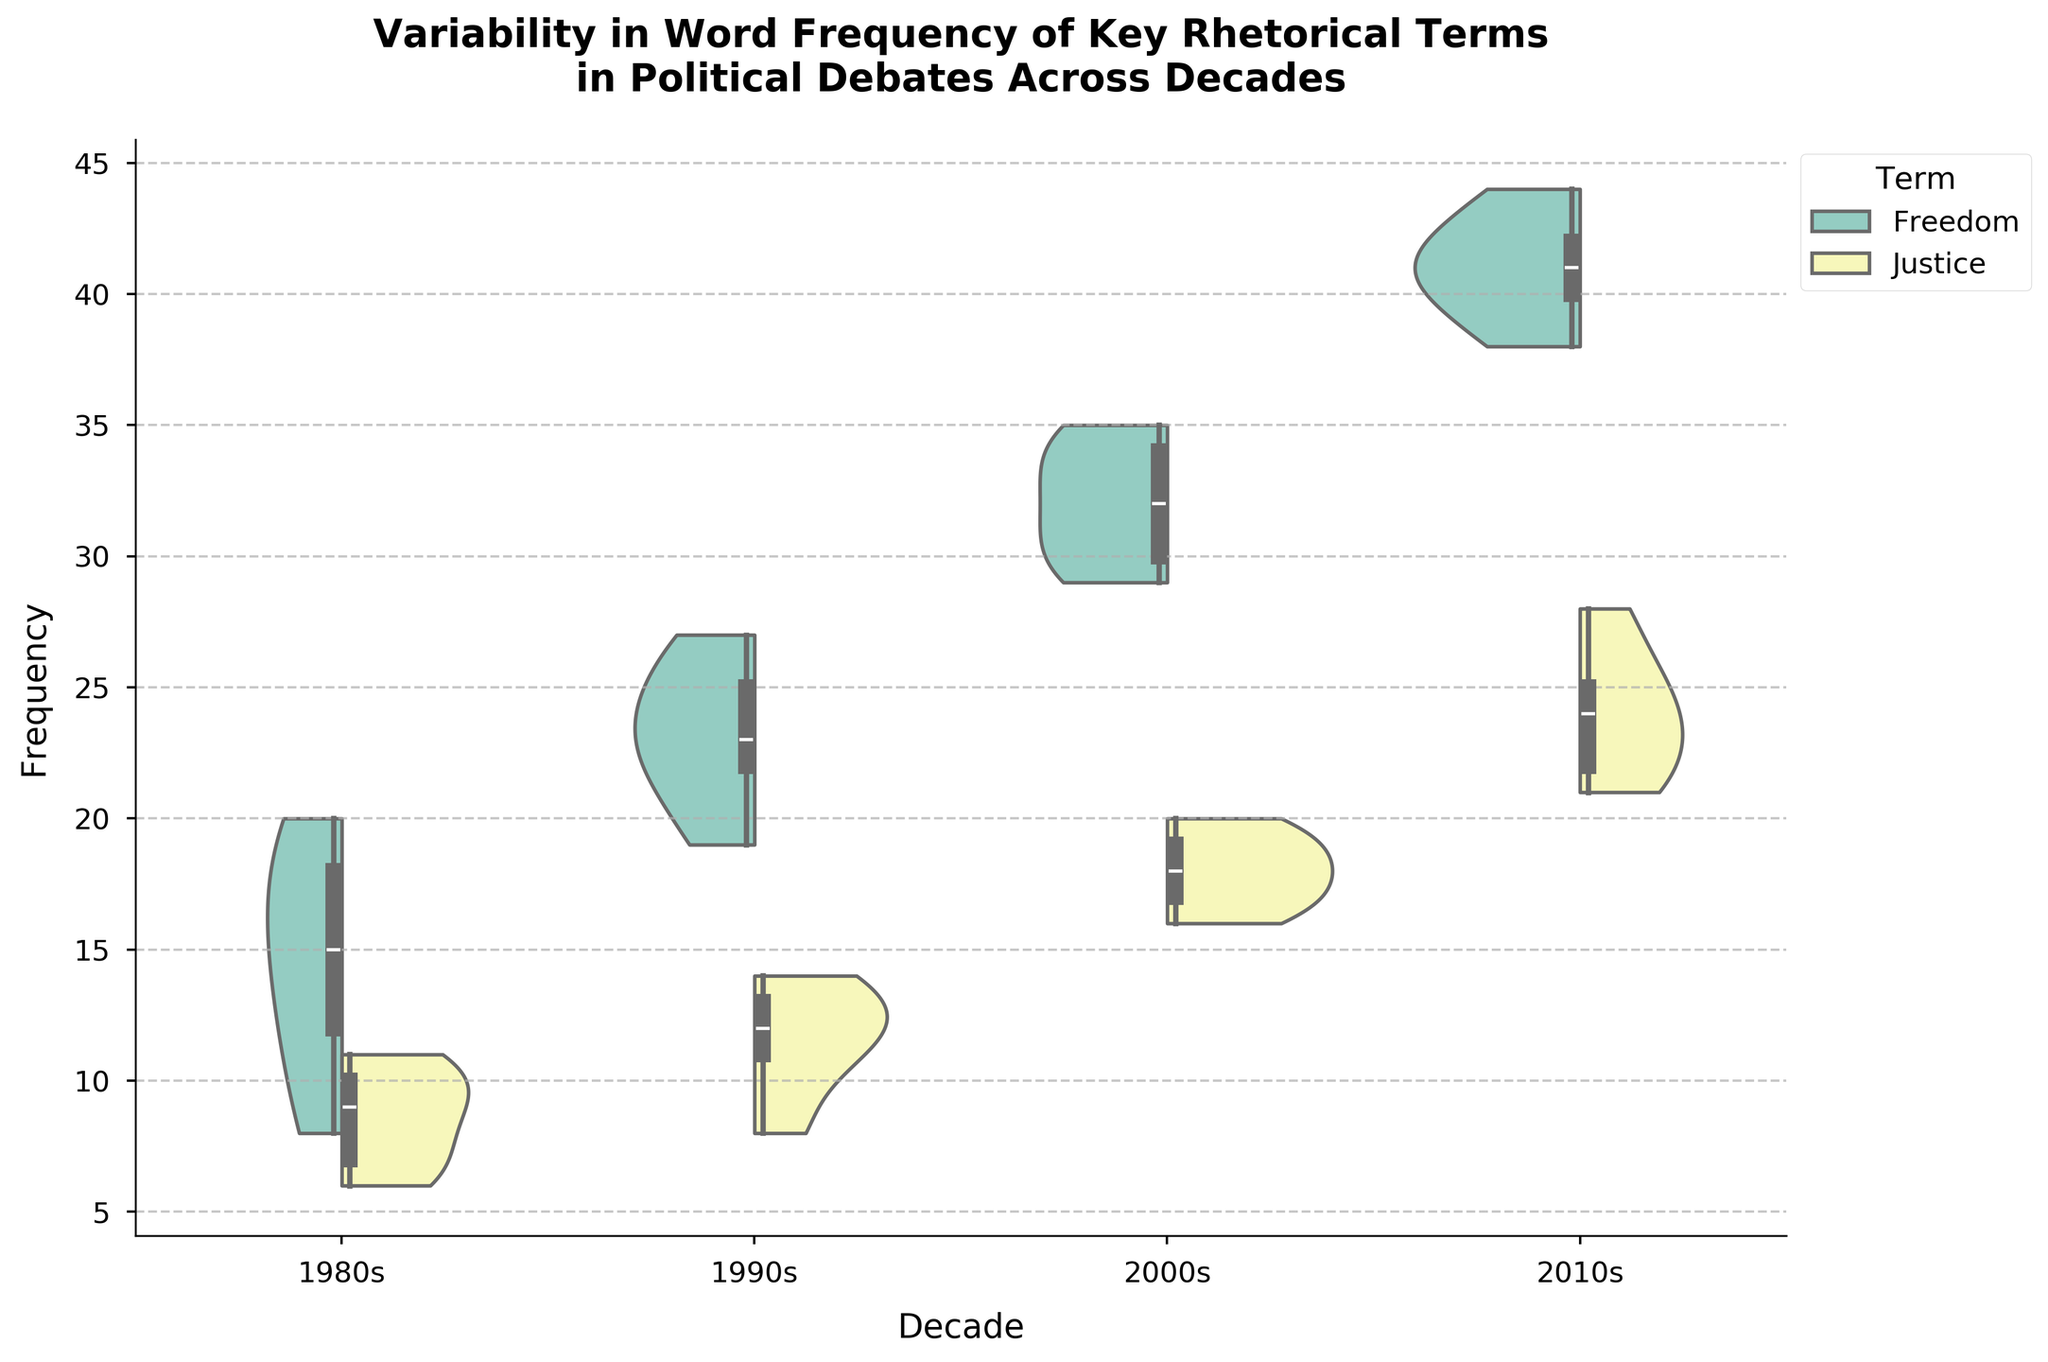What's the title of the chart? The title is located at the top of the chart and typically summarizes the main subject of the visual representation. It reads "Variability in Word Frequency of Key Rhetorical Terms in Political Debates Across Decades".
Answer: Variability in Word Frequency of Key Rhetorical Terms in Political Debates Across Decades Which rhetorical term appears more frequently in the 2010s, "Freedom" or "Justice"? By comparing the violin plots for "Freedom" and "Justice" in the 2010s, we observe that the frequency range of "Freedom" is consistently higher than that of "Justice".
Answer: Freedom What is the general trend in the frequency of the term "Freedom" from the 1980s to the 2010s? Observing the violin plots across each decade, the median and general spread of the frequency of the term "Freedom" increases over time from the 1980s to the 2010s.
Answer: Increasing In which decade does the term "Justice" have the widest distribution of frequencies? By looking at the width of the violin plots, the decade with the most spread (largest variability) for the term "Justice" is the 2010s.
Answer: 2010s How does the median frequency of the term "Freedom" in the 1990s compare to the median frequency in the 2000s? In the violin plots, the median is indicated by the thickest part of the box plot overlay. The median frequency of "Freedom" in the 1990s is lower than in the 2000s.
Answer: Lower in the 1990s What is the range of frequencies for the term "Justice" in the 2000s? The range of frequencies can be determined by the extent of the violin plot. For "Justice" in the 2000s, the frequency ranges from 16 to 20.
Answer: 16 to 20 Which term has a higher median frequency in the 1980s? By comparing the thickest part of the box plot overlays in the 1980s for both terms, the term "Freedom" has a higher median frequency compared to "Justice".
Answer: Freedom How has the use of the term "Freedom" changed between the 1990s and 2010s? Comparing the violin plots and box plot overlays for both decades, the term "Freedom" has shown an increase in both median frequency and overall distribution from the 1990s to the 2010s.
Answer: Increased Is there any decade where the median frequencies of "Freedom" and "Justice" are approximately equal? By observing the medians indicated by the box plot overlays for each decade, there is no decade where the median frequencies of "Freedom" and "Justice" are approximately equal; they always differ.
Answer: No 